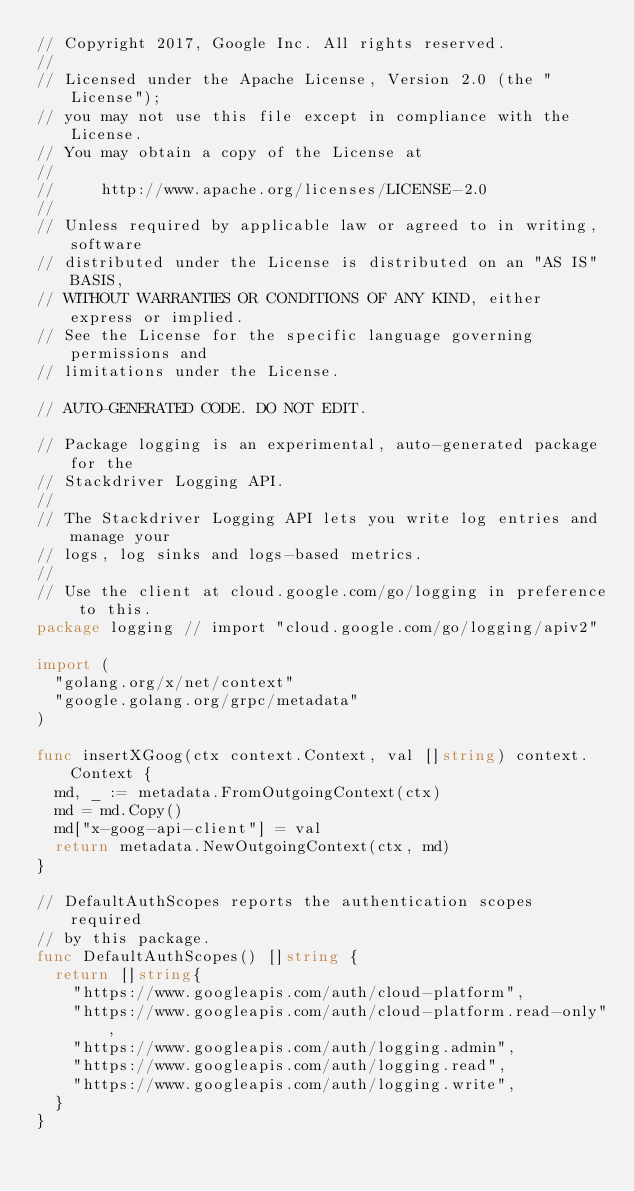Convert code to text. <code><loc_0><loc_0><loc_500><loc_500><_Go_>// Copyright 2017, Google Inc. All rights reserved.
//
// Licensed under the Apache License, Version 2.0 (the "License");
// you may not use this file except in compliance with the License.
// You may obtain a copy of the License at
//
//     http://www.apache.org/licenses/LICENSE-2.0
//
// Unless required by applicable law or agreed to in writing, software
// distributed under the License is distributed on an "AS IS" BASIS,
// WITHOUT WARRANTIES OR CONDITIONS OF ANY KIND, either express or implied.
// See the License for the specific language governing permissions and
// limitations under the License.

// AUTO-GENERATED CODE. DO NOT EDIT.

// Package logging is an experimental, auto-generated package for the
// Stackdriver Logging API.
//
// The Stackdriver Logging API lets you write log entries and manage your
// logs, log sinks and logs-based metrics.
//
// Use the client at cloud.google.com/go/logging in preference to this.
package logging // import "cloud.google.com/go/logging/apiv2"

import (
	"golang.org/x/net/context"
	"google.golang.org/grpc/metadata"
)

func insertXGoog(ctx context.Context, val []string) context.Context {
	md, _ := metadata.FromOutgoingContext(ctx)
	md = md.Copy()
	md["x-goog-api-client"] = val
	return metadata.NewOutgoingContext(ctx, md)
}

// DefaultAuthScopes reports the authentication scopes required
// by this package.
func DefaultAuthScopes() []string {
	return []string{
		"https://www.googleapis.com/auth/cloud-platform",
		"https://www.googleapis.com/auth/cloud-platform.read-only",
		"https://www.googleapis.com/auth/logging.admin",
		"https://www.googleapis.com/auth/logging.read",
		"https://www.googleapis.com/auth/logging.write",
	}
}
</code> 